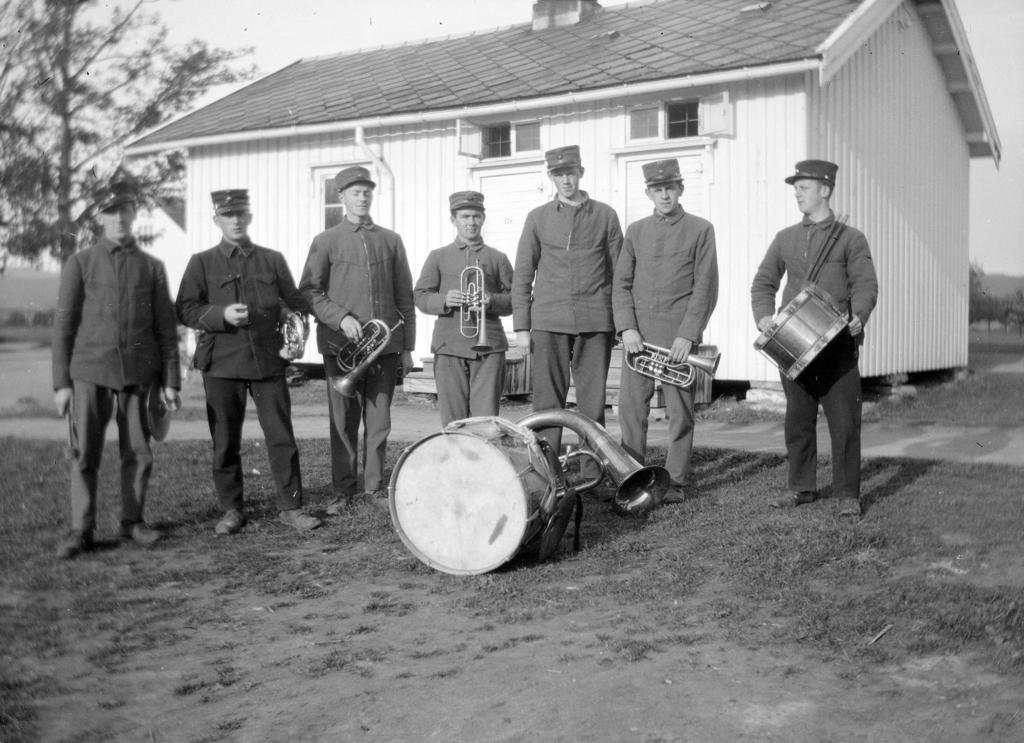What are the persons in the center of the image doing? The persons in the center of the image are holding instruments. What type of instrument can be seen in the front of the image? A drum is visible in the front of the image. What can be seen in the background of the image? There is a house and a tree in the background of the image. What type of drain is visible in the image? There is no drain present in the image. How many pans are being used by the persons in the image? There is no pan visible in the image, and the persons are holding instruments, not pans. 